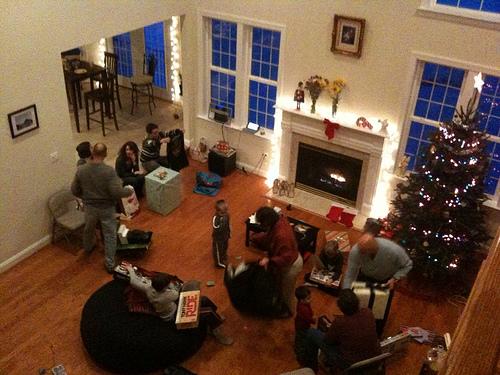Is the Christmas tree decorated nicely?
Give a very brief answer. Yes. What holiday are they celebrating?
Answer briefly. Christmas. Where are the Christmas stockings?
Short answer required. No. 